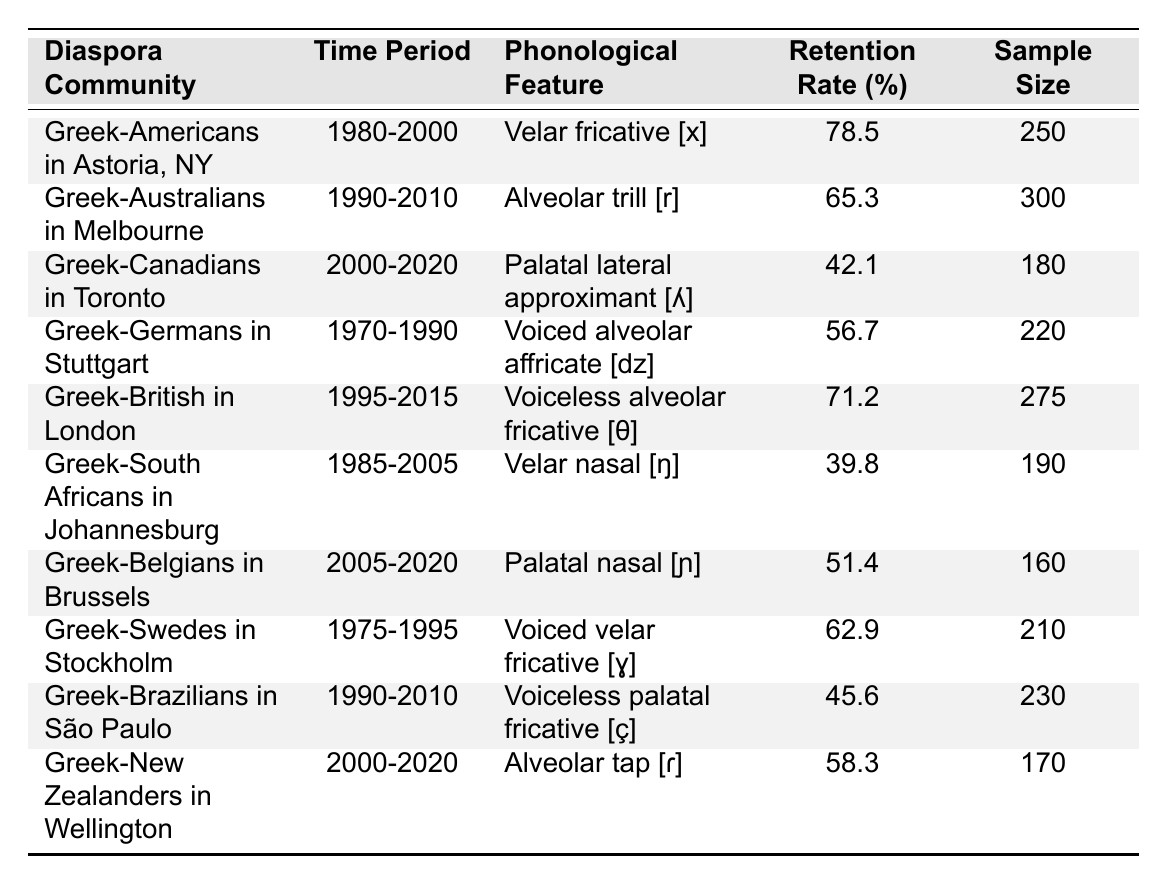What is the highest retention rate among the diaspora communities listed? The table includes various retention rates, and upon reviewing the values, the highest retention rate is 78.5% for Greek-Americans in Astoria, NY.
Answer: 78.5% Which phonological feature had the lowest retention rate in the table? By examining the retention rates, the palatal lateral approximant [ʎ] has the lowest retention rate at 42.1% among the listed features.
Answer: Palatal lateral approximant [ʎ] How many samples were included for the Greek-Australians in Melbourne? The table shows a sample size of 300 for Greek-Australians in Melbourne between 1990-2010.
Answer: 300 What is the average retention rate for the Greek communities in the table? To find the average, sum the retention rates (78.5 + 65.3 + 42.1 + 56.7 + 71.2 + 39.8 + 51.4 + 62.9 + 45.6 + 58.3 =  570.8) and then divide by the number of communities (10). The average retention rate is 570.8 / 10 = 57.08%.
Answer: 57.08% Is the retention rate for Greek-South Africans in Johannesburg higher than that of Greek-Canadians in Toronto? The retention rate for Greek-South Africans is 39.8%, while for Greek-Canadians it is 42.1%. Since 39.8% is less than 42.1%, the statement is false.
Answer: No Which two communities had retention rates above 70%? By reviewing the table, Greek-Americans in Astoria (78.5%) and Greek-British in London (71.2%) are the only two communities with retention rates above 70%.
Answer: Greek-Americans in Astoria and Greek-British in London What is the difference in retention rates between Greek-Brazilians in São Paulo and Greek-Belgians in Brussels? Greek-Brazilians have a retention rate of 45.6%, and Greek-Belgians have 51.4%. The difference is calculated as 51.4 - 45.6 = 5.8%.
Answer: 5.8% Which time period shows the longest span of data for a single community? The data for Greek-Australians in Melbourne covers a span from 1990 to 2010, which is a period of 20 years, the longest among the communities listed.
Answer: 20 years Do any diaspora communities have a retention rate below 50%? Yes, Greek-Canadians in Toronto (42.1%), Greek-South Africans in Johannesburg (39.8%), and Greek-Brazilians in São Paulo (45.6%) all have retention rates below 50%.
Answer: Yes What phonological feature did Greek-Swedes in Stockholm retain, and what was its retention rate? Greek-Swedes retained the voiced velar fricative [ɣ] with a retention rate of 62.9%.
Answer: Voiced velar fricative [ɣ], 62.9% 